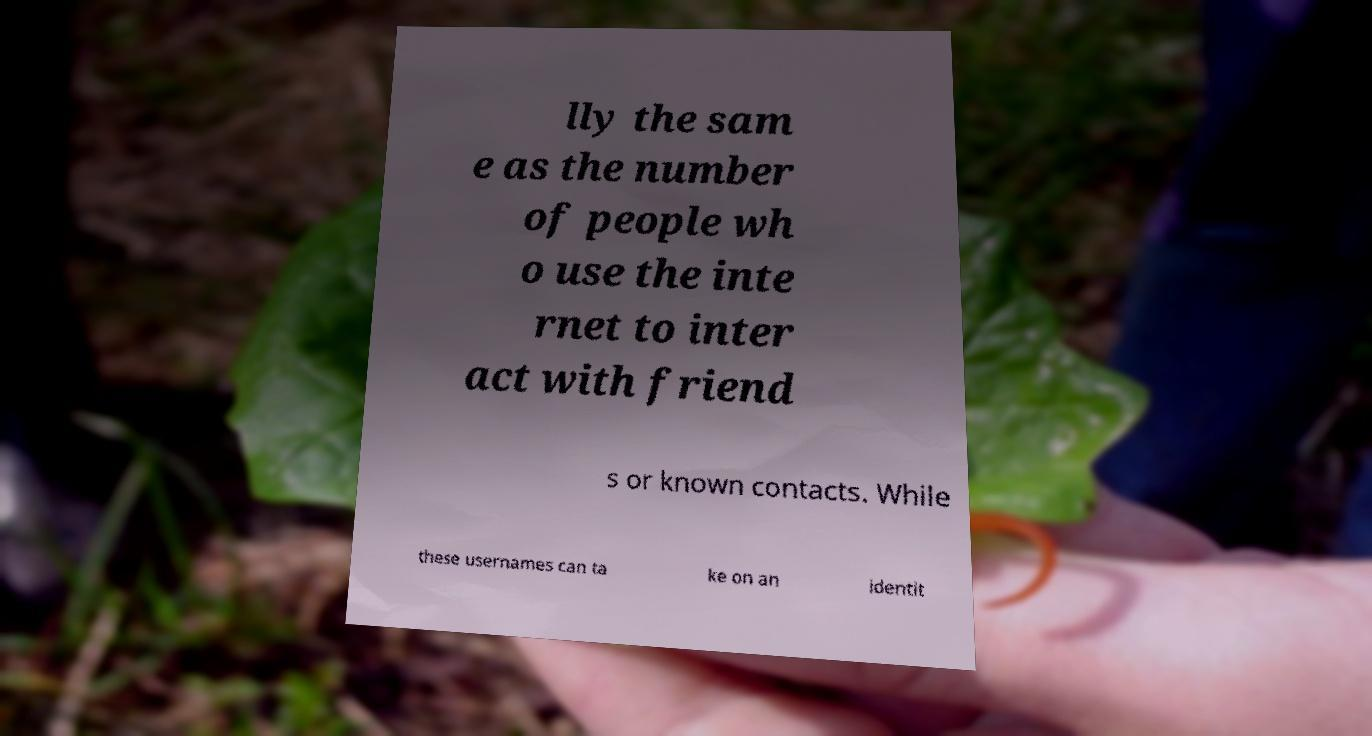Could you extract and type out the text from this image? lly the sam e as the number of people wh o use the inte rnet to inter act with friend s or known contacts. While these usernames can ta ke on an identit 